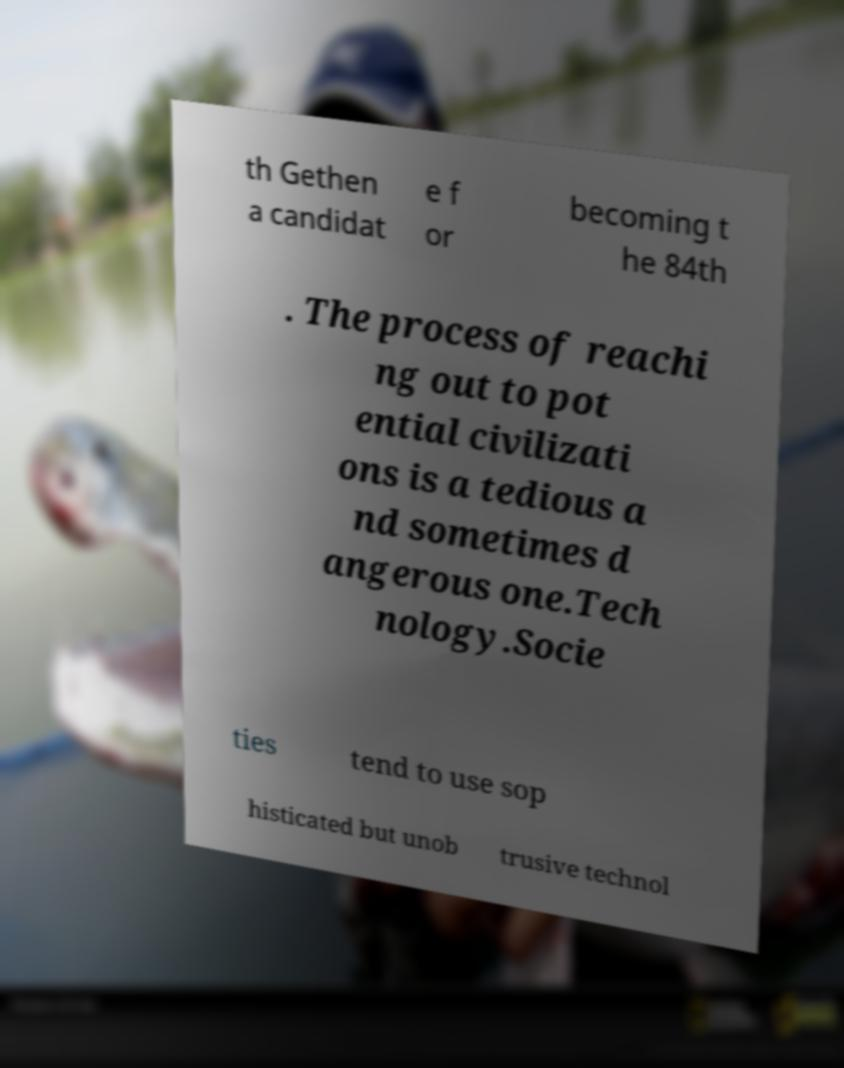Can you accurately transcribe the text from the provided image for me? th Gethen a candidat e f or becoming t he 84th . The process of reachi ng out to pot ential civilizati ons is a tedious a nd sometimes d angerous one.Tech nology.Socie ties tend to use sop histicated but unob trusive technol 